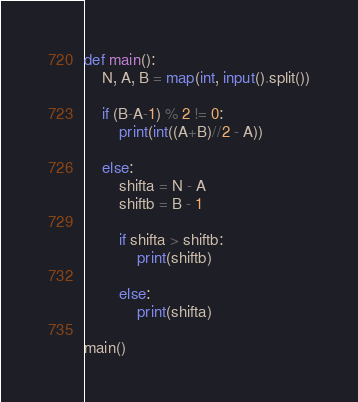Convert code to text. <code><loc_0><loc_0><loc_500><loc_500><_Python_>def main():
    N, A, B = map(int, input().split())

    if (B-A-1) % 2 != 0:
        print(int((A+B)//2 - A))

    else:
        shifta = N - A
        shiftb = B - 1

        if shifta > shiftb:
            print(shiftb)

        else:
            print(shifta)

main()
</code> 